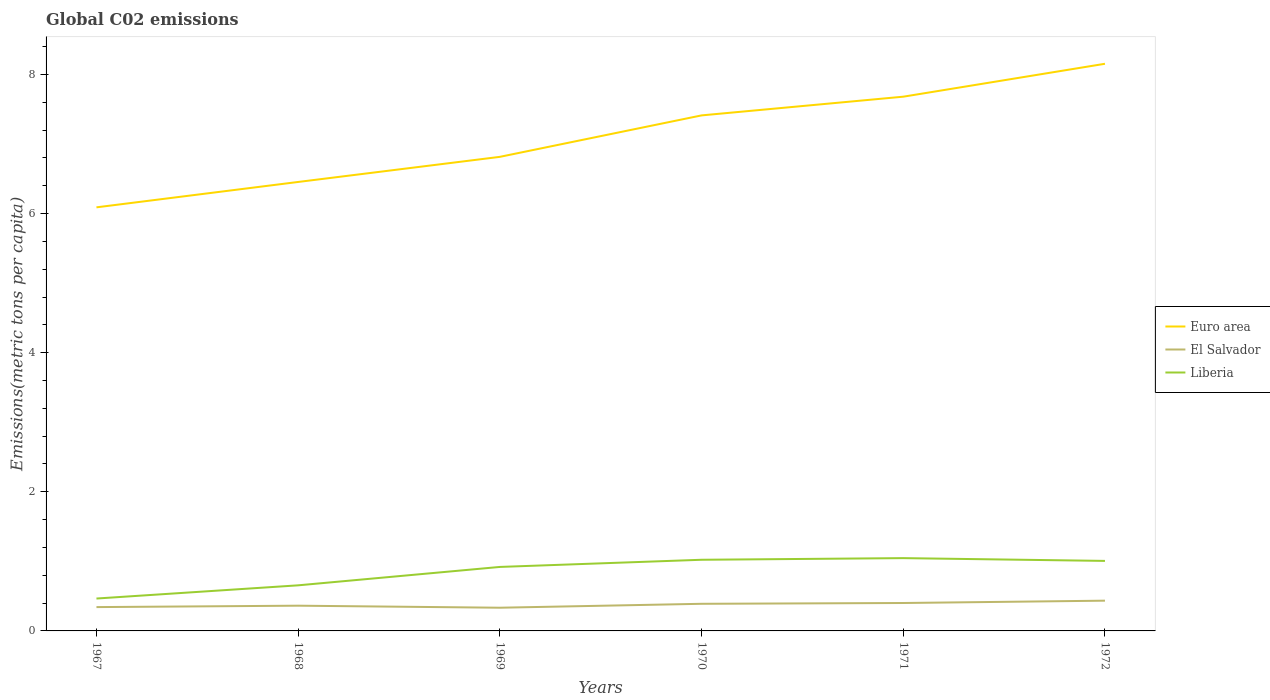Does the line corresponding to El Salvador intersect with the line corresponding to Liberia?
Your response must be concise. No. Is the number of lines equal to the number of legend labels?
Provide a succinct answer. Yes. Across all years, what is the maximum amount of CO2 emitted in in Euro area?
Your answer should be compact. 6.09. In which year was the amount of CO2 emitted in in El Salvador maximum?
Provide a short and direct response. 1969. What is the total amount of CO2 emitted in in El Salvador in the graph?
Your answer should be compact. 0.03. What is the difference between the highest and the second highest amount of CO2 emitted in in Liberia?
Keep it short and to the point. 0.58. What is the difference between the highest and the lowest amount of CO2 emitted in in Euro area?
Provide a short and direct response. 3. How many lines are there?
Offer a terse response. 3. Does the graph contain grids?
Provide a succinct answer. No. How many legend labels are there?
Ensure brevity in your answer.  3. How are the legend labels stacked?
Your response must be concise. Vertical. What is the title of the graph?
Your response must be concise. Global C02 emissions. What is the label or title of the X-axis?
Your response must be concise. Years. What is the label or title of the Y-axis?
Your response must be concise. Emissions(metric tons per capita). What is the Emissions(metric tons per capita) in Euro area in 1967?
Ensure brevity in your answer.  6.09. What is the Emissions(metric tons per capita) of El Salvador in 1967?
Your response must be concise. 0.34. What is the Emissions(metric tons per capita) of Liberia in 1967?
Give a very brief answer. 0.47. What is the Emissions(metric tons per capita) in Euro area in 1968?
Offer a very short reply. 6.45. What is the Emissions(metric tons per capita) in El Salvador in 1968?
Give a very brief answer. 0.36. What is the Emissions(metric tons per capita) of Liberia in 1968?
Provide a short and direct response. 0.66. What is the Emissions(metric tons per capita) in Euro area in 1969?
Your answer should be very brief. 6.81. What is the Emissions(metric tons per capita) of El Salvador in 1969?
Your response must be concise. 0.33. What is the Emissions(metric tons per capita) of Liberia in 1969?
Offer a terse response. 0.92. What is the Emissions(metric tons per capita) of Euro area in 1970?
Provide a succinct answer. 7.41. What is the Emissions(metric tons per capita) of El Salvador in 1970?
Your answer should be very brief. 0.39. What is the Emissions(metric tons per capita) of Liberia in 1970?
Ensure brevity in your answer.  1.02. What is the Emissions(metric tons per capita) of Euro area in 1971?
Offer a terse response. 7.68. What is the Emissions(metric tons per capita) in El Salvador in 1971?
Give a very brief answer. 0.4. What is the Emissions(metric tons per capita) in Liberia in 1971?
Give a very brief answer. 1.05. What is the Emissions(metric tons per capita) of Euro area in 1972?
Keep it short and to the point. 8.15. What is the Emissions(metric tons per capita) in El Salvador in 1972?
Offer a terse response. 0.43. What is the Emissions(metric tons per capita) in Liberia in 1972?
Provide a short and direct response. 1.01. Across all years, what is the maximum Emissions(metric tons per capita) in Euro area?
Your response must be concise. 8.15. Across all years, what is the maximum Emissions(metric tons per capita) in El Salvador?
Keep it short and to the point. 0.43. Across all years, what is the maximum Emissions(metric tons per capita) in Liberia?
Offer a terse response. 1.05. Across all years, what is the minimum Emissions(metric tons per capita) of Euro area?
Provide a succinct answer. 6.09. Across all years, what is the minimum Emissions(metric tons per capita) of El Salvador?
Your answer should be compact. 0.33. Across all years, what is the minimum Emissions(metric tons per capita) of Liberia?
Offer a very short reply. 0.47. What is the total Emissions(metric tons per capita) in Euro area in the graph?
Provide a short and direct response. 42.6. What is the total Emissions(metric tons per capita) of El Salvador in the graph?
Your response must be concise. 2.26. What is the total Emissions(metric tons per capita) of Liberia in the graph?
Provide a short and direct response. 5.12. What is the difference between the Emissions(metric tons per capita) in Euro area in 1967 and that in 1968?
Your answer should be compact. -0.36. What is the difference between the Emissions(metric tons per capita) of El Salvador in 1967 and that in 1968?
Offer a very short reply. -0.02. What is the difference between the Emissions(metric tons per capita) in Liberia in 1967 and that in 1968?
Your response must be concise. -0.19. What is the difference between the Emissions(metric tons per capita) of Euro area in 1967 and that in 1969?
Make the answer very short. -0.73. What is the difference between the Emissions(metric tons per capita) of El Salvador in 1967 and that in 1969?
Ensure brevity in your answer.  0.01. What is the difference between the Emissions(metric tons per capita) of Liberia in 1967 and that in 1969?
Offer a terse response. -0.45. What is the difference between the Emissions(metric tons per capita) in Euro area in 1967 and that in 1970?
Your response must be concise. -1.32. What is the difference between the Emissions(metric tons per capita) of El Salvador in 1967 and that in 1970?
Your answer should be compact. -0.05. What is the difference between the Emissions(metric tons per capita) of Liberia in 1967 and that in 1970?
Provide a succinct answer. -0.56. What is the difference between the Emissions(metric tons per capita) in Euro area in 1967 and that in 1971?
Offer a terse response. -1.59. What is the difference between the Emissions(metric tons per capita) in El Salvador in 1967 and that in 1971?
Make the answer very short. -0.06. What is the difference between the Emissions(metric tons per capita) in Liberia in 1967 and that in 1971?
Provide a short and direct response. -0.58. What is the difference between the Emissions(metric tons per capita) in Euro area in 1967 and that in 1972?
Your response must be concise. -2.06. What is the difference between the Emissions(metric tons per capita) of El Salvador in 1967 and that in 1972?
Give a very brief answer. -0.09. What is the difference between the Emissions(metric tons per capita) of Liberia in 1967 and that in 1972?
Your response must be concise. -0.54. What is the difference between the Emissions(metric tons per capita) of Euro area in 1968 and that in 1969?
Keep it short and to the point. -0.36. What is the difference between the Emissions(metric tons per capita) of El Salvador in 1968 and that in 1969?
Ensure brevity in your answer.  0.03. What is the difference between the Emissions(metric tons per capita) in Liberia in 1968 and that in 1969?
Provide a short and direct response. -0.26. What is the difference between the Emissions(metric tons per capita) of Euro area in 1968 and that in 1970?
Ensure brevity in your answer.  -0.96. What is the difference between the Emissions(metric tons per capita) in El Salvador in 1968 and that in 1970?
Your answer should be compact. -0.03. What is the difference between the Emissions(metric tons per capita) in Liberia in 1968 and that in 1970?
Your answer should be compact. -0.37. What is the difference between the Emissions(metric tons per capita) in Euro area in 1968 and that in 1971?
Ensure brevity in your answer.  -1.23. What is the difference between the Emissions(metric tons per capita) in El Salvador in 1968 and that in 1971?
Your response must be concise. -0.04. What is the difference between the Emissions(metric tons per capita) in Liberia in 1968 and that in 1971?
Give a very brief answer. -0.39. What is the difference between the Emissions(metric tons per capita) of Euro area in 1968 and that in 1972?
Offer a terse response. -1.7. What is the difference between the Emissions(metric tons per capita) of El Salvador in 1968 and that in 1972?
Keep it short and to the point. -0.07. What is the difference between the Emissions(metric tons per capita) of Liberia in 1968 and that in 1972?
Your response must be concise. -0.35. What is the difference between the Emissions(metric tons per capita) in Euro area in 1969 and that in 1970?
Your answer should be very brief. -0.6. What is the difference between the Emissions(metric tons per capita) in El Salvador in 1969 and that in 1970?
Ensure brevity in your answer.  -0.06. What is the difference between the Emissions(metric tons per capita) of Liberia in 1969 and that in 1970?
Offer a very short reply. -0.1. What is the difference between the Emissions(metric tons per capita) in Euro area in 1969 and that in 1971?
Your response must be concise. -0.86. What is the difference between the Emissions(metric tons per capita) of El Salvador in 1969 and that in 1971?
Your answer should be compact. -0.07. What is the difference between the Emissions(metric tons per capita) of Liberia in 1969 and that in 1971?
Offer a very short reply. -0.13. What is the difference between the Emissions(metric tons per capita) in Euro area in 1969 and that in 1972?
Provide a succinct answer. -1.34. What is the difference between the Emissions(metric tons per capita) of El Salvador in 1969 and that in 1972?
Your answer should be very brief. -0.1. What is the difference between the Emissions(metric tons per capita) in Liberia in 1969 and that in 1972?
Provide a succinct answer. -0.09. What is the difference between the Emissions(metric tons per capita) of Euro area in 1970 and that in 1971?
Your answer should be compact. -0.27. What is the difference between the Emissions(metric tons per capita) of El Salvador in 1970 and that in 1971?
Offer a very short reply. -0.01. What is the difference between the Emissions(metric tons per capita) of Liberia in 1970 and that in 1971?
Make the answer very short. -0.02. What is the difference between the Emissions(metric tons per capita) of Euro area in 1970 and that in 1972?
Your answer should be compact. -0.74. What is the difference between the Emissions(metric tons per capita) in El Salvador in 1970 and that in 1972?
Your answer should be very brief. -0.04. What is the difference between the Emissions(metric tons per capita) of Liberia in 1970 and that in 1972?
Make the answer very short. 0.02. What is the difference between the Emissions(metric tons per capita) of Euro area in 1971 and that in 1972?
Provide a short and direct response. -0.47. What is the difference between the Emissions(metric tons per capita) of El Salvador in 1971 and that in 1972?
Keep it short and to the point. -0.03. What is the difference between the Emissions(metric tons per capita) in Liberia in 1971 and that in 1972?
Your response must be concise. 0.04. What is the difference between the Emissions(metric tons per capita) of Euro area in 1967 and the Emissions(metric tons per capita) of El Salvador in 1968?
Offer a terse response. 5.73. What is the difference between the Emissions(metric tons per capita) of Euro area in 1967 and the Emissions(metric tons per capita) of Liberia in 1968?
Your answer should be very brief. 5.43. What is the difference between the Emissions(metric tons per capita) of El Salvador in 1967 and the Emissions(metric tons per capita) of Liberia in 1968?
Give a very brief answer. -0.31. What is the difference between the Emissions(metric tons per capita) in Euro area in 1967 and the Emissions(metric tons per capita) in El Salvador in 1969?
Provide a short and direct response. 5.76. What is the difference between the Emissions(metric tons per capita) in Euro area in 1967 and the Emissions(metric tons per capita) in Liberia in 1969?
Keep it short and to the point. 5.17. What is the difference between the Emissions(metric tons per capita) of El Salvador in 1967 and the Emissions(metric tons per capita) of Liberia in 1969?
Provide a succinct answer. -0.58. What is the difference between the Emissions(metric tons per capita) in Euro area in 1967 and the Emissions(metric tons per capita) in El Salvador in 1970?
Make the answer very short. 5.7. What is the difference between the Emissions(metric tons per capita) of Euro area in 1967 and the Emissions(metric tons per capita) of Liberia in 1970?
Offer a very short reply. 5.07. What is the difference between the Emissions(metric tons per capita) of El Salvador in 1967 and the Emissions(metric tons per capita) of Liberia in 1970?
Offer a very short reply. -0.68. What is the difference between the Emissions(metric tons per capita) of Euro area in 1967 and the Emissions(metric tons per capita) of El Salvador in 1971?
Give a very brief answer. 5.69. What is the difference between the Emissions(metric tons per capita) in Euro area in 1967 and the Emissions(metric tons per capita) in Liberia in 1971?
Offer a very short reply. 5.04. What is the difference between the Emissions(metric tons per capita) in El Salvador in 1967 and the Emissions(metric tons per capita) in Liberia in 1971?
Offer a terse response. -0.7. What is the difference between the Emissions(metric tons per capita) of Euro area in 1967 and the Emissions(metric tons per capita) of El Salvador in 1972?
Your answer should be compact. 5.65. What is the difference between the Emissions(metric tons per capita) of Euro area in 1967 and the Emissions(metric tons per capita) of Liberia in 1972?
Keep it short and to the point. 5.08. What is the difference between the Emissions(metric tons per capita) of El Salvador in 1967 and the Emissions(metric tons per capita) of Liberia in 1972?
Make the answer very short. -0.66. What is the difference between the Emissions(metric tons per capita) of Euro area in 1968 and the Emissions(metric tons per capita) of El Salvador in 1969?
Provide a succinct answer. 6.12. What is the difference between the Emissions(metric tons per capita) in Euro area in 1968 and the Emissions(metric tons per capita) in Liberia in 1969?
Offer a terse response. 5.53. What is the difference between the Emissions(metric tons per capita) in El Salvador in 1968 and the Emissions(metric tons per capita) in Liberia in 1969?
Give a very brief answer. -0.56. What is the difference between the Emissions(metric tons per capita) of Euro area in 1968 and the Emissions(metric tons per capita) of El Salvador in 1970?
Keep it short and to the point. 6.06. What is the difference between the Emissions(metric tons per capita) of Euro area in 1968 and the Emissions(metric tons per capita) of Liberia in 1970?
Provide a short and direct response. 5.43. What is the difference between the Emissions(metric tons per capita) in El Salvador in 1968 and the Emissions(metric tons per capita) in Liberia in 1970?
Give a very brief answer. -0.66. What is the difference between the Emissions(metric tons per capita) of Euro area in 1968 and the Emissions(metric tons per capita) of El Salvador in 1971?
Ensure brevity in your answer.  6.05. What is the difference between the Emissions(metric tons per capita) in Euro area in 1968 and the Emissions(metric tons per capita) in Liberia in 1971?
Offer a very short reply. 5.41. What is the difference between the Emissions(metric tons per capita) in El Salvador in 1968 and the Emissions(metric tons per capita) in Liberia in 1971?
Your answer should be very brief. -0.68. What is the difference between the Emissions(metric tons per capita) in Euro area in 1968 and the Emissions(metric tons per capita) in El Salvador in 1972?
Provide a short and direct response. 6.02. What is the difference between the Emissions(metric tons per capita) of Euro area in 1968 and the Emissions(metric tons per capita) of Liberia in 1972?
Offer a terse response. 5.45. What is the difference between the Emissions(metric tons per capita) of El Salvador in 1968 and the Emissions(metric tons per capita) of Liberia in 1972?
Offer a terse response. -0.64. What is the difference between the Emissions(metric tons per capita) of Euro area in 1969 and the Emissions(metric tons per capita) of El Salvador in 1970?
Your answer should be compact. 6.42. What is the difference between the Emissions(metric tons per capita) in Euro area in 1969 and the Emissions(metric tons per capita) in Liberia in 1970?
Offer a very short reply. 5.79. What is the difference between the Emissions(metric tons per capita) of El Salvador in 1969 and the Emissions(metric tons per capita) of Liberia in 1970?
Ensure brevity in your answer.  -0.69. What is the difference between the Emissions(metric tons per capita) of Euro area in 1969 and the Emissions(metric tons per capita) of El Salvador in 1971?
Provide a succinct answer. 6.41. What is the difference between the Emissions(metric tons per capita) in Euro area in 1969 and the Emissions(metric tons per capita) in Liberia in 1971?
Your answer should be compact. 5.77. What is the difference between the Emissions(metric tons per capita) in El Salvador in 1969 and the Emissions(metric tons per capita) in Liberia in 1971?
Give a very brief answer. -0.71. What is the difference between the Emissions(metric tons per capita) in Euro area in 1969 and the Emissions(metric tons per capita) in El Salvador in 1972?
Provide a short and direct response. 6.38. What is the difference between the Emissions(metric tons per capita) in Euro area in 1969 and the Emissions(metric tons per capita) in Liberia in 1972?
Keep it short and to the point. 5.81. What is the difference between the Emissions(metric tons per capita) of El Salvador in 1969 and the Emissions(metric tons per capita) of Liberia in 1972?
Your response must be concise. -0.67. What is the difference between the Emissions(metric tons per capita) of Euro area in 1970 and the Emissions(metric tons per capita) of El Salvador in 1971?
Offer a terse response. 7.01. What is the difference between the Emissions(metric tons per capita) of Euro area in 1970 and the Emissions(metric tons per capita) of Liberia in 1971?
Keep it short and to the point. 6.36. What is the difference between the Emissions(metric tons per capita) in El Salvador in 1970 and the Emissions(metric tons per capita) in Liberia in 1971?
Ensure brevity in your answer.  -0.66. What is the difference between the Emissions(metric tons per capita) in Euro area in 1970 and the Emissions(metric tons per capita) in El Salvador in 1972?
Give a very brief answer. 6.98. What is the difference between the Emissions(metric tons per capita) of Euro area in 1970 and the Emissions(metric tons per capita) of Liberia in 1972?
Give a very brief answer. 6.4. What is the difference between the Emissions(metric tons per capita) in El Salvador in 1970 and the Emissions(metric tons per capita) in Liberia in 1972?
Offer a terse response. -0.62. What is the difference between the Emissions(metric tons per capita) in Euro area in 1971 and the Emissions(metric tons per capita) in El Salvador in 1972?
Provide a succinct answer. 7.24. What is the difference between the Emissions(metric tons per capita) of Euro area in 1971 and the Emissions(metric tons per capita) of Liberia in 1972?
Ensure brevity in your answer.  6.67. What is the difference between the Emissions(metric tons per capita) in El Salvador in 1971 and the Emissions(metric tons per capita) in Liberia in 1972?
Make the answer very short. -0.61. What is the average Emissions(metric tons per capita) in El Salvador per year?
Your answer should be very brief. 0.38. What is the average Emissions(metric tons per capita) of Liberia per year?
Give a very brief answer. 0.85. In the year 1967, what is the difference between the Emissions(metric tons per capita) in Euro area and Emissions(metric tons per capita) in El Salvador?
Offer a terse response. 5.75. In the year 1967, what is the difference between the Emissions(metric tons per capita) in Euro area and Emissions(metric tons per capita) in Liberia?
Your response must be concise. 5.62. In the year 1967, what is the difference between the Emissions(metric tons per capita) of El Salvador and Emissions(metric tons per capita) of Liberia?
Your answer should be compact. -0.12. In the year 1968, what is the difference between the Emissions(metric tons per capita) of Euro area and Emissions(metric tons per capita) of El Salvador?
Ensure brevity in your answer.  6.09. In the year 1968, what is the difference between the Emissions(metric tons per capita) of Euro area and Emissions(metric tons per capita) of Liberia?
Your response must be concise. 5.8. In the year 1968, what is the difference between the Emissions(metric tons per capita) of El Salvador and Emissions(metric tons per capita) of Liberia?
Give a very brief answer. -0.29. In the year 1969, what is the difference between the Emissions(metric tons per capita) in Euro area and Emissions(metric tons per capita) in El Salvador?
Offer a very short reply. 6.48. In the year 1969, what is the difference between the Emissions(metric tons per capita) of Euro area and Emissions(metric tons per capita) of Liberia?
Your response must be concise. 5.89. In the year 1969, what is the difference between the Emissions(metric tons per capita) of El Salvador and Emissions(metric tons per capita) of Liberia?
Your answer should be compact. -0.59. In the year 1970, what is the difference between the Emissions(metric tons per capita) of Euro area and Emissions(metric tons per capita) of El Salvador?
Ensure brevity in your answer.  7.02. In the year 1970, what is the difference between the Emissions(metric tons per capita) in Euro area and Emissions(metric tons per capita) in Liberia?
Your answer should be very brief. 6.39. In the year 1970, what is the difference between the Emissions(metric tons per capita) in El Salvador and Emissions(metric tons per capita) in Liberia?
Your response must be concise. -0.63. In the year 1971, what is the difference between the Emissions(metric tons per capita) in Euro area and Emissions(metric tons per capita) in El Salvador?
Your answer should be compact. 7.28. In the year 1971, what is the difference between the Emissions(metric tons per capita) of Euro area and Emissions(metric tons per capita) of Liberia?
Give a very brief answer. 6.63. In the year 1971, what is the difference between the Emissions(metric tons per capita) in El Salvador and Emissions(metric tons per capita) in Liberia?
Make the answer very short. -0.65. In the year 1972, what is the difference between the Emissions(metric tons per capita) in Euro area and Emissions(metric tons per capita) in El Salvador?
Give a very brief answer. 7.72. In the year 1972, what is the difference between the Emissions(metric tons per capita) of Euro area and Emissions(metric tons per capita) of Liberia?
Your response must be concise. 7.15. In the year 1972, what is the difference between the Emissions(metric tons per capita) of El Salvador and Emissions(metric tons per capita) of Liberia?
Your response must be concise. -0.57. What is the ratio of the Emissions(metric tons per capita) of Euro area in 1967 to that in 1968?
Ensure brevity in your answer.  0.94. What is the ratio of the Emissions(metric tons per capita) of El Salvador in 1967 to that in 1968?
Make the answer very short. 0.94. What is the ratio of the Emissions(metric tons per capita) of Liberia in 1967 to that in 1968?
Provide a succinct answer. 0.71. What is the ratio of the Emissions(metric tons per capita) in Euro area in 1967 to that in 1969?
Your response must be concise. 0.89. What is the ratio of the Emissions(metric tons per capita) in El Salvador in 1967 to that in 1969?
Your response must be concise. 1.03. What is the ratio of the Emissions(metric tons per capita) in Liberia in 1967 to that in 1969?
Offer a terse response. 0.51. What is the ratio of the Emissions(metric tons per capita) in Euro area in 1967 to that in 1970?
Give a very brief answer. 0.82. What is the ratio of the Emissions(metric tons per capita) in El Salvador in 1967 to that in 1970?
Provide a short and direct response. 0.88. What is the ratio of the Emissions(metric tons per capita) of Liberia in 1967 to that in 1970?
Keep it short and to the point. 0.46. What is the ratio of the Emissions(metric tons per capita) in Euro area in 1967 to that in 1971?
Provide a succinct answer. 0.79. What is the ratio of the Emissions(metric tons per capita) of El Salvador in 1967 to that in 1971?
Ensure brevity in your answer.  0.85. What is the ratio of the Emissions(metric tons per capita) of Liberia in 1967 to that in 1971?
Your answer should be very brief. 0.45. What is the ratio of the Emissions(metric tons per capita) of Euro area in 1967 to that in 1972?
Your answer should be compact. 0.75. What is the ratio of the Emissions(metric tons per capita) of El Salvador in 1967 to that in 1972?
Offer a very short reply. 0.79. What is the ratio of the Emissions(metric tons per capita) of Liberia in 1967 to that in 1972?
Give a very brief answer. 0.46. What is the ratio of the Emissions(metric tons per capita) in Euro area in 1968 to that in 1969?
Your answer should be compact. 0.95. What is the ratio of the Emissions(metric tons per capita) in El Salvador in 1968 to that in 1969?
Offer a terse response. 1.09. What is the ratio of the Emissions(metric tons per capita) in Liberia in 1968 to that in 1969?
Keep it short and to the point. 0.71. What is the ratio of the Emissions(metric tons per capita) in Euro area in 1968 to that in 1970?
Keep it short and to the point. 0.87. What is the ratio of the Emissions(metric tons per capita) in El Salvador in 1968 to that in 1970?
Ensure brevity in your answer.  0.93. What is the ratio of the Emissions(metric tons per capita) of Liberia in 1968 to that in 1970?
Give a very brief answer. 0.64. What is the ratio of the Emissions(metric tons per capita) in Euro area in 1968 to that in 1971?
Give a very brief answer. 0.84. What is the ratio of the Emissions(metric tons per capita) in El Salvador in 1968 to that in 1971?
Offer a terse response. 0.9. What is the ratio of the Emissions(metric tons per capita) in Liberia in 1968 to that in 1971?
Your response must be concise. 0.63. What is the ratio of the Emissions(metric tons per capita) in Euro area in 1968 to that in 1972?
Provide a short and direct response. 0.79. What is the ratio of the Emissions(metric tons per capita) of El Salvador in 1968 to that in 1972?
Give a very brief answer. 0.83. What is the ratio of the Emissions(metric tons per capita) of Liberia in 1968 to that in 1972?
Ensure brevity in your answer.  0.65. What is the ratio of the Emissions(metric tons per capita) in Euro area in 1969 to that in 1970?
Your answer should be compact. 0.92. What is the ratio of the Emissions(metric tons per capita) of El Salvador in 1969 to that in 1970?
Provide a short and direct response. 0.86. What is the ratio of the Emissions(metric tons per capita) in Liberia in 1969 to that in 1970?
Give a very brief answer. 0.9. What is the ratio of the Emissions(metric tons per capita) in Euro area in 1969 to that in 1971?
Your response must be concise. 0.89. What is the ratio of the Emissions(metric tons per capita) of El Salvador in 1969 to that in 1971?
Provide a short and direct response. 0.83. What is the ratio of the Emissions(metric tons per capita) in Liberia in 1969 to that in 1971?
Offer a very short reply. 0.88. What is the ratio of the Emissions(metric tons per capita) of Euro area in 1969 to that in 1972?
Your answer should be compact. 0.84. What is the ratio of the Emissions(metric tons per capita) of El Salvador in 1969 to that in 1972?
Ensure brevity in your answer.  0.77. What is the ratio of the Emissions(metric tons per capita) of Liberia in 1969 to that in 1972?
Your answer should be very brief. 0.91. What is the ratio of the Emissions(metric tons per capita) of Euro area in 1970 to that in 1971?
Provide a succinct answer. 0.96. What is the ratio of the Emissions(metric tons per capita) in El Salvador in 1970 to that in 1971?
Give a very brief answer. 0.97. What is the ratio of the Emissions(metric tons per capita) of Liberia in 1970 to that in 1971?
Your answer should be very brief. 0.98. What is the ratio of the Emissions(metric tons per capita) in Euro area in 1970 to that in 1972?
Ensure brevity in your answer.  0.91. What is the ratio of the Emissions(metric tons per capita) of El Salvador in 1970 to that in 1972?
Your answer should be very brief. 0.9. What is the ratio of the Emissions(metric tons per capita) of Liberia in 1970 to that in 1972?
Your answer should be very brief. 1.02. What is the ratio of the Emissions(metric tons per capita) in Euro area in 1971 to that in 1972?
Your response must be concise. 0.94. What is the ratio of the Emissions(metric tons per capita) of El Salvador in 1971 to that in 1972?
Provide a succinct answer. 0.92. What is the ratio of the Emissions(metric tons per capita) of Liberia in 1971 to that in 1972?
Offer a terse response. 1.04. What is the difference between the highest and the second highest Emissions(metric tons per capita) in Euro area?
Provide a succinct answer. 0.47. What is the difference between the highest and the second highest Emissions(metric tons per capita) in El Salvador?
Keep it short and to the point. 0.03. What is the difference between the highest and the second highest Emissions(metric tons per capita) of Liberia?
Offer a very short reply. 0.02. What is the difference between the highest and the lowest Emissions(metric tons per capita) of Euro area?
Provide a succinct answer. 2.06. What is the difference between the highest and the lowest Emissions(metric tons per capita) in El Salvador?
Offer a very short reply. 0.1. What is the difference between the highest and the lowest Emissions(metric tons per capita) of Liberia?
Offer a very short reply. 0.58. 